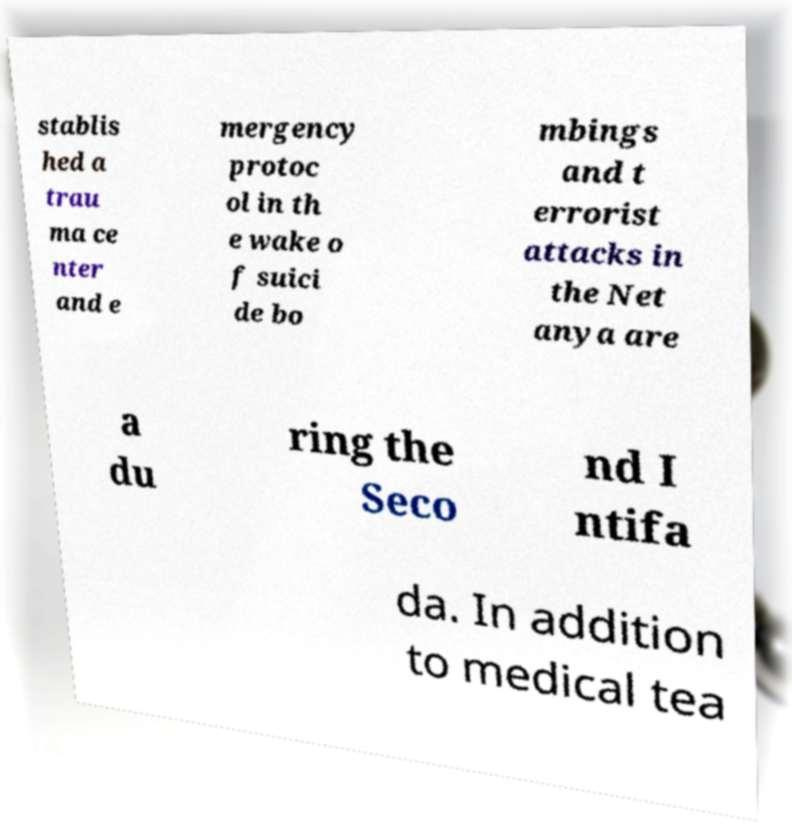Can you read and provide the text displayed in the image?This photo seems to have some interesting text. Can you extract and type it out for me? stablis hed a trau ma ce nter and e mergency protoc ol in th e wake o f suici de bo mbings and t errorist attacks in the Net anya are a du ring the Seco nd I ntifa da. In addition to medical tea 